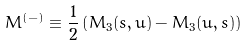<formula> <loc_0><loc_0><loc_500><loc_500>M ^ { ( - ) } \equiv \frac { 1 } { 2 } \left ( M _ { 3 } ( s , u ) - M _ { 3 } ( u , s ) \right )</formula> 